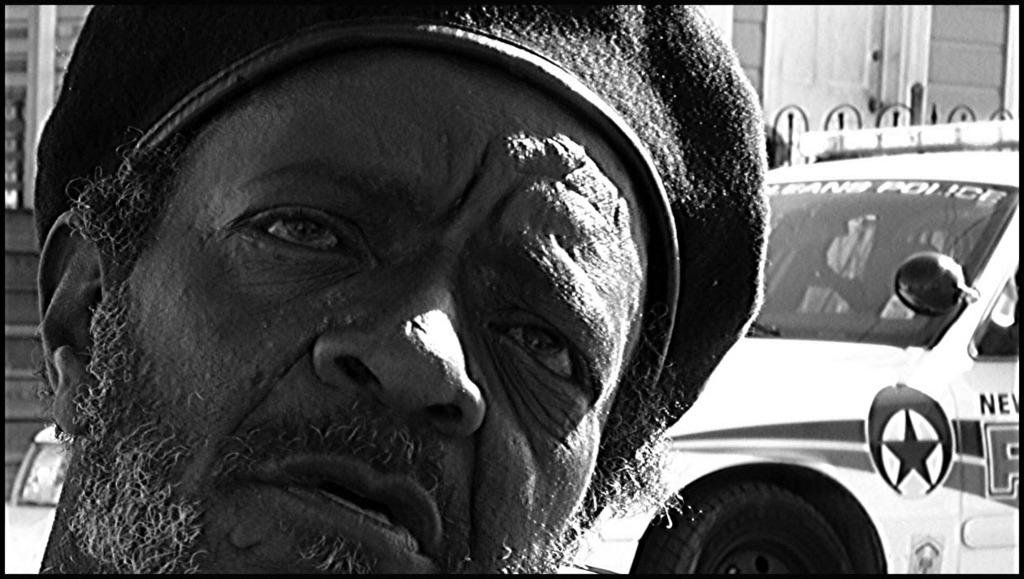What is the color scheme of the image? The image is in black and white. Can you describe the man on the left side of the image? There is a man with a hat on the left side of the image. What can be seen on the right side of the image? There is a vehicle on the right side of the image. Is the man in the image giving birth to a child? There is no indication of a birth or child in the image; it features a man with a hat and a vehicle. What type of bait is being used by the man in the image? There is no bait present in the image; it only features a man with a hat and a vehicle. 